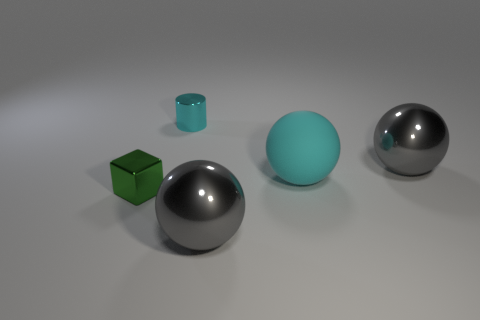What size is the cylinder that is the same color as the matte ball?
Ensure brevity in your answer.  Small. There is a tiny green object; is its shape the same as the big gray metal object that is to the right of the cyan sphere?
Your response must be concise. No. Is the color of the tiny cube the same as the big ball right of the large cyan rubber ball?
Your answer should be compact. No. How many other objects are there of the same size as the green block?
Give a very brief answer. 1. There is a large gray object that is in front of the big gray metal object to the right of the cyan object that is in front of the cyan metal cylinder; what shape is it?
Offer a terse response. Sphere. Do the matte sphere and the gray thing that is in front of the tiny green metallic block have the same size?
Provide a short and direct response. Yes. There is a metallic thing that is to the left of the matte sphere and behind the small green metal block; what color is it?
Your answer should be compact. Cyan. What number of other things are the same shape as the cyan rubber thing?
Provide a succinct answer. 2. Is the color of the big object behind the big rubber sphere the same as the small object that is behind the small green shiny thing?
Your response must be concise. No. There is a gray thing that is on the right side of the big cyan thing; is its size the same as the ball that is left of the big cyan rubber sphere?
Give a very brief answer. Yes. 